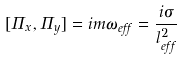<formula> <loc_0><loc_0><loc_500><loc_500>[ \Pi _ { x } , \Pi _ { y } ] = i m \omega _ { e f f } = \frac { i \sigma } { l _ { e f f } ^ { 2 } }</formula> 